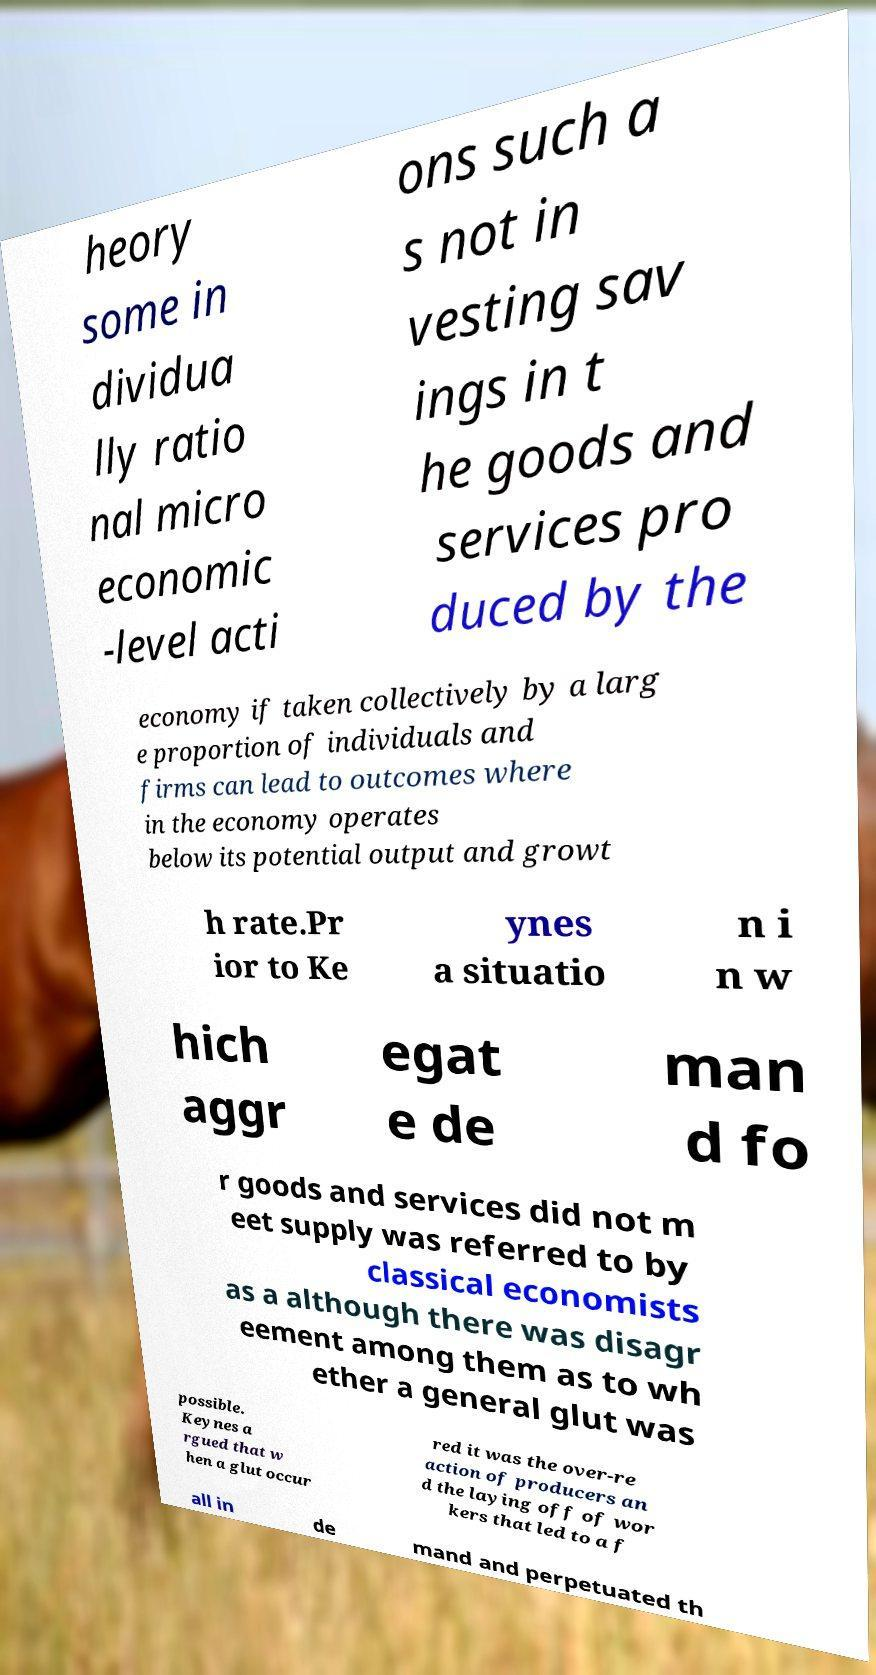Please identify and transcribe the text found in this image. heory some in dividua lly ratio nal micro economic -level acti ons such a s not in vesting sav ings in t he goods and services pro duced by the economy if taken collectively by a larg e proportion of individuals and firms can lead to outcomes where in the economy operates below its potential output and growt h rate.Pr ior to Ke ynes a situatio n i n w hich aggr egat e de man d fo r goods and services did not m eet supply was referred to by classical economists as a although there was disagr eement among them as to wh ether a general glut was possible. Keynes a rgued that w hen a glut occur red it was the over-re action of producers an d the laying off of wor kers that led to a f all in de mand and perpetuated th 